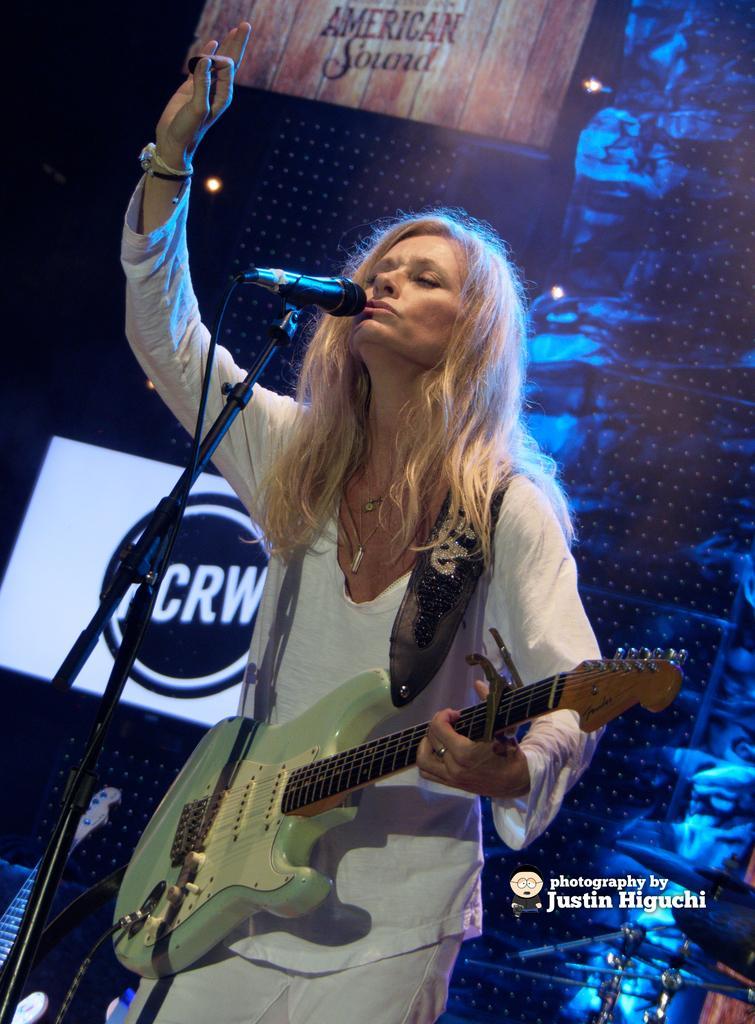Please provide a concise description of this image. As we can see in the image, there is a women holding guitar and in front of the women there is a mic and in the background there are posters. 